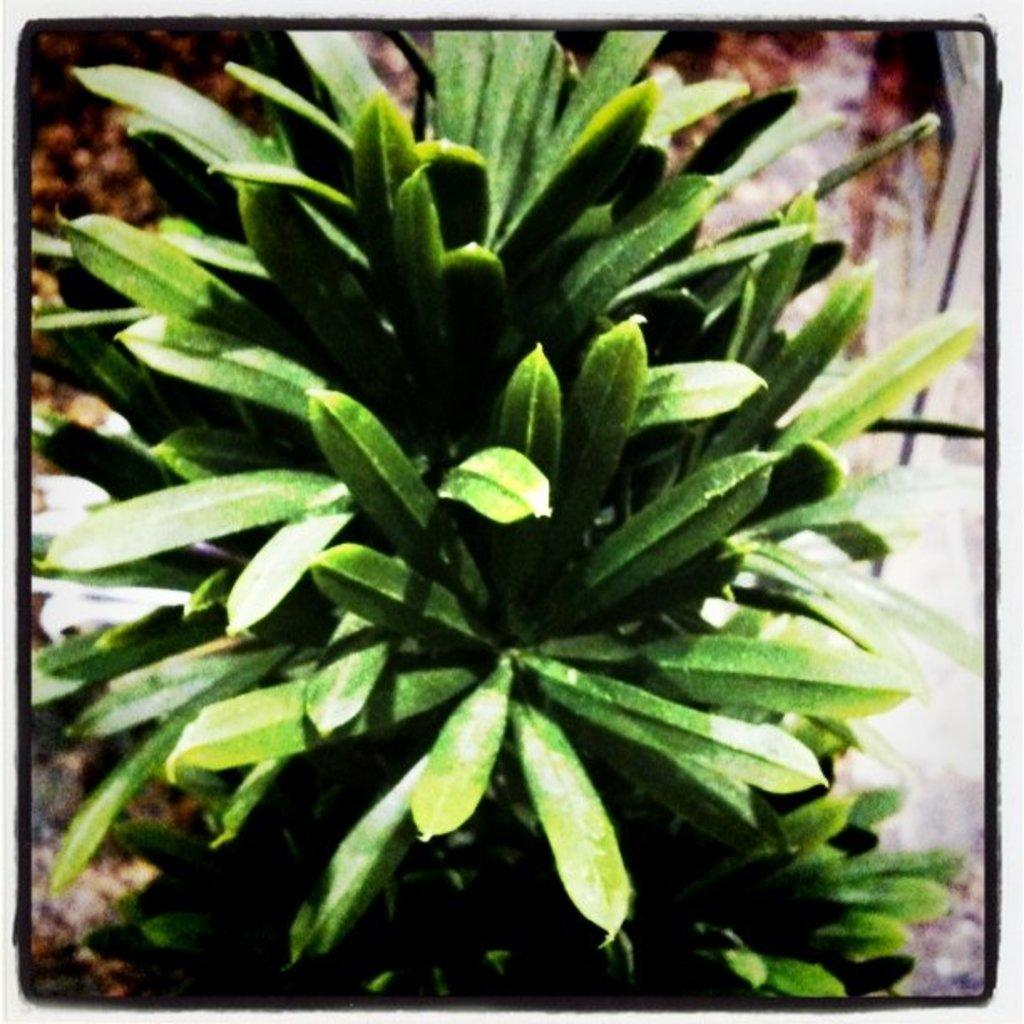What type of living organism can be seen in the image? There is a plant in the image. What is the color of the plant? The plant is green in color. What color are the borders of the plant? The borders of the plant are black. How many brothers are depicted in the image? There are no brothers present in the image; it features a plant with black borders. What type of boats can be seen sailing in the image? There are no boats present in the image; it features a plant with black borders. 